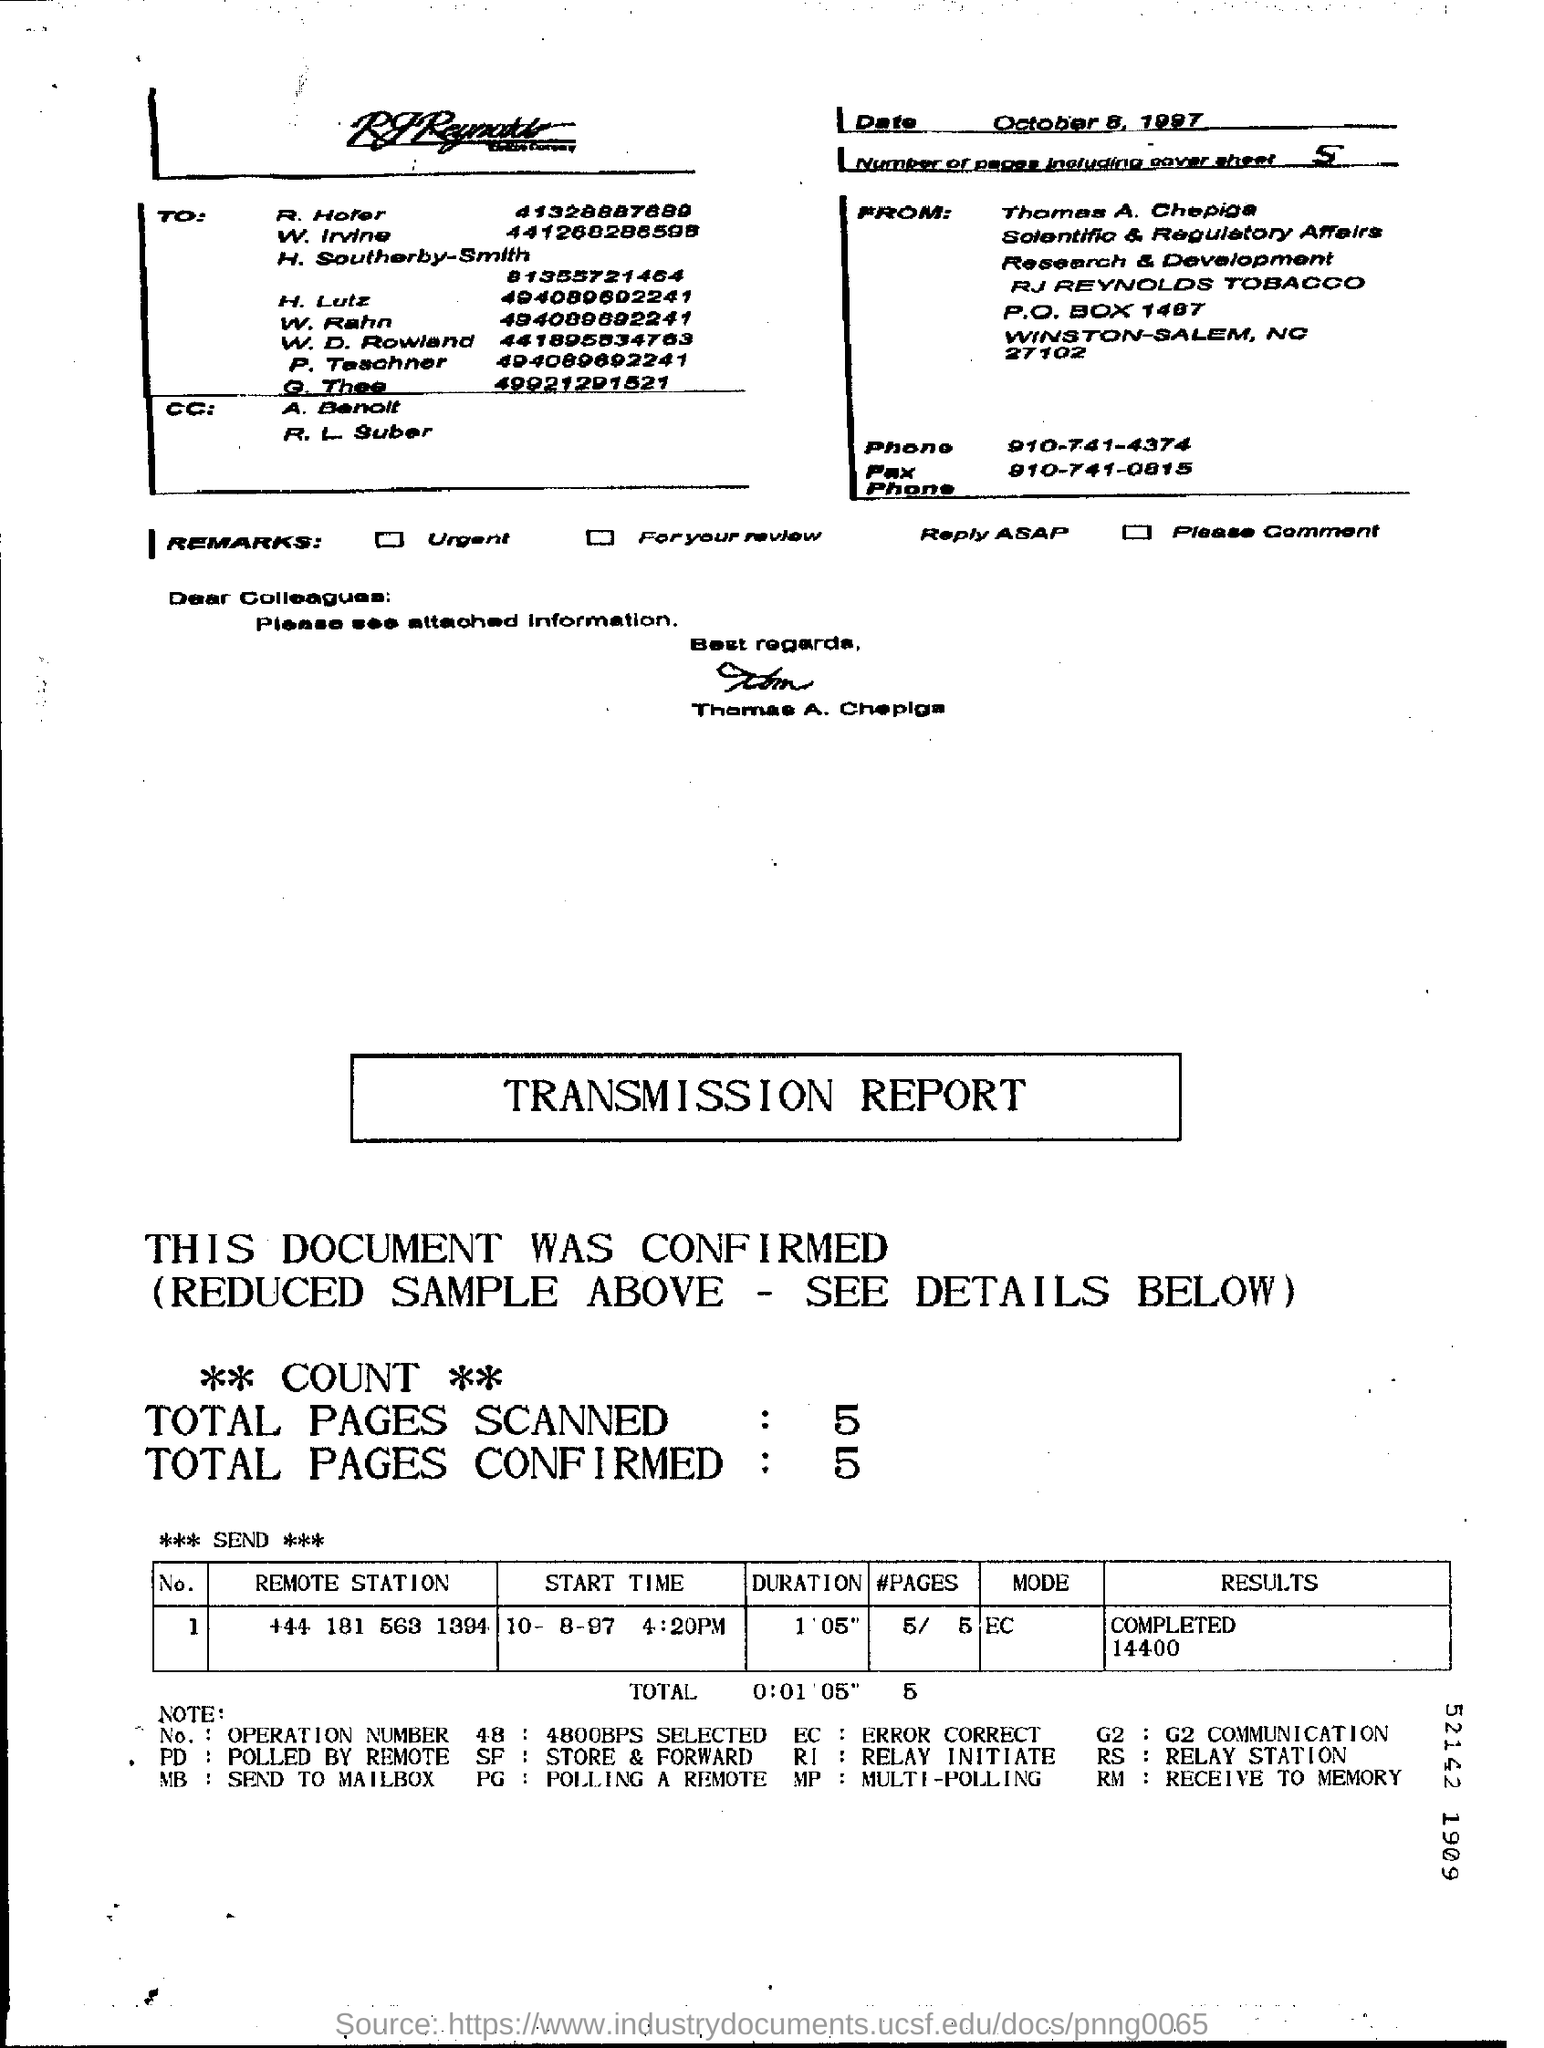Identify some key points in this picture. The mode of the transmission report is EC. The phone number of Thomas A. Chepiga is 910-741-0815. The remote station associated with Operation Number 1 is +44 181 563 1394. The person who sent this message is named Thomas. The number of pages in the fax, including the cover sheet, is five. 